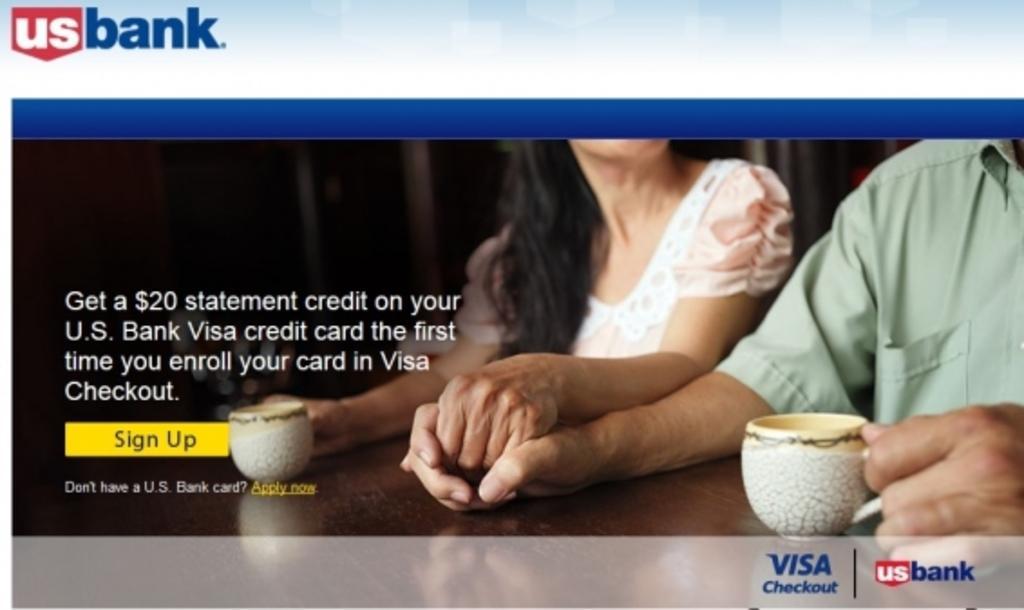How would you summarize this image in a sentence or two? This is a poster and in this poster we can see a man and a woman, cups on the table and some text. 